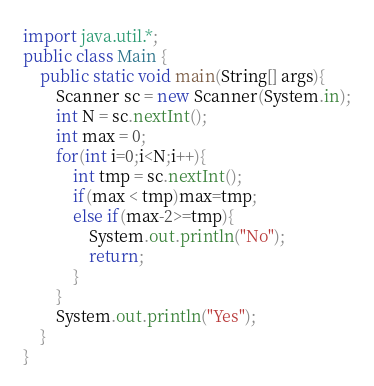Convert code to text. <code><loc_0><loc_0><loc_500><loc_500><_Java_>import java.util.*;
public class Main {
	public static void main(String[] args){
		Scanner sc = new Scanner(System.in);
		int N = sc.nextInt();
		int max = 0;
		for(int i=0;i<N;i++){
			int tmp = sc.nextInt();
			if(max < tmp)max=tmp;
			else if(max-2>=tmp){
				System.out.println("No");
				return;
			}
		}
		System.out.println("Yes");
	}
}</code> 